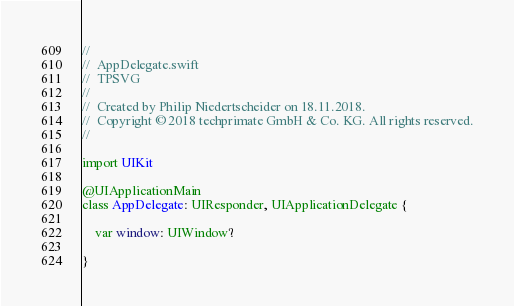<code> <loc_0><loc_0><loc_500><loc_500><_Swift_>//
//  AppDelegate.swift
//  TPSVG
//
//  Created by Philip Niedertscheider on 18.11.2018.
//  Copyright © 2018 techprimate GmbH & Co. KG. All rights reserved.
//

import UIKit

@UIApplicationMain
class AppDelegate: UIResponder, UIApplicationDelegate {

    var window: UIWindow?

}
</code> 